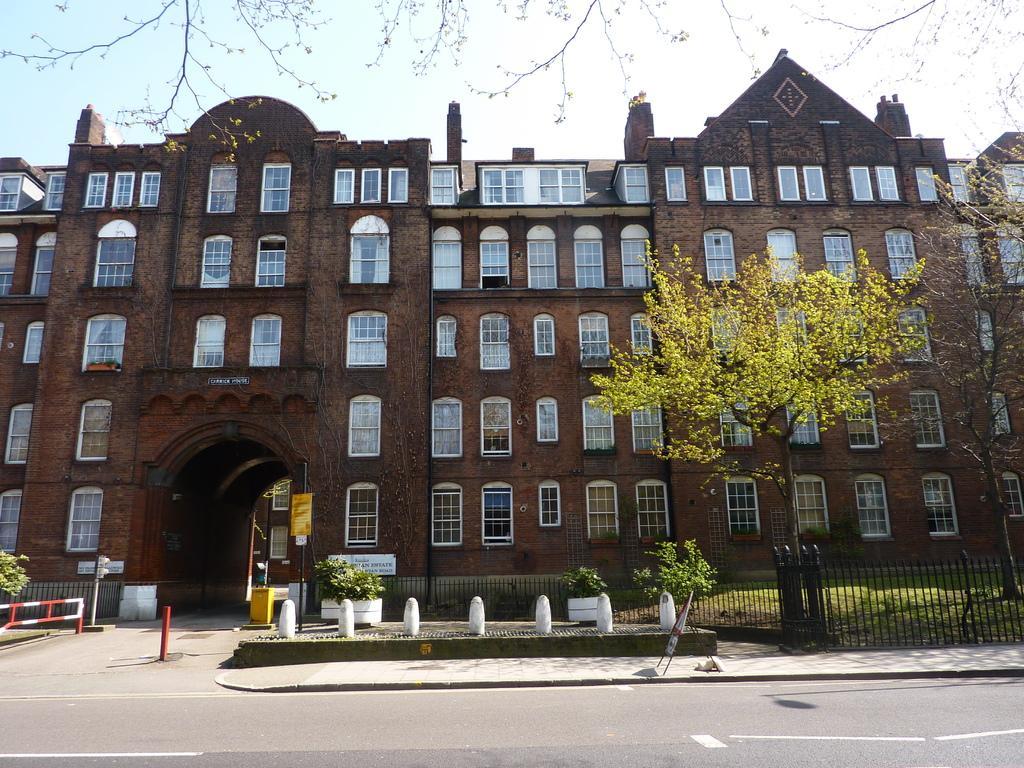Please provide a concise description of this image. At the center of the image there is a building, in front of the building there are poles and stones and there are trees, plants and grass surrounded with fencing. In the background there is a sky. 